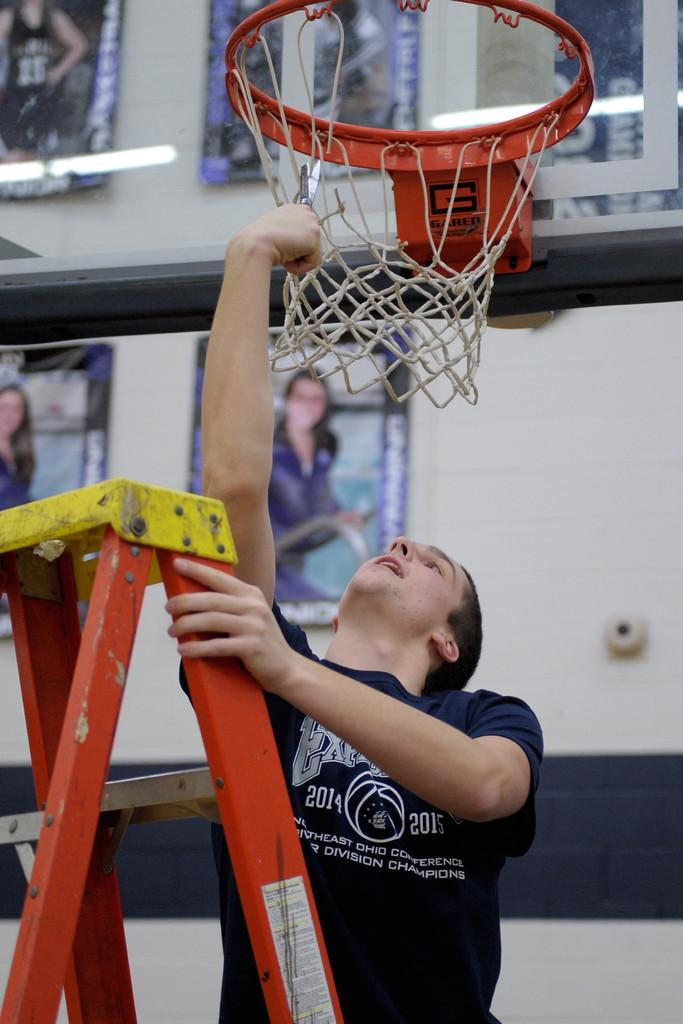<image>
Relay a brief, clear account of the picture shown. A person on a ladder cuts down a never in a shirt that says 2014 and 2015 on it. 